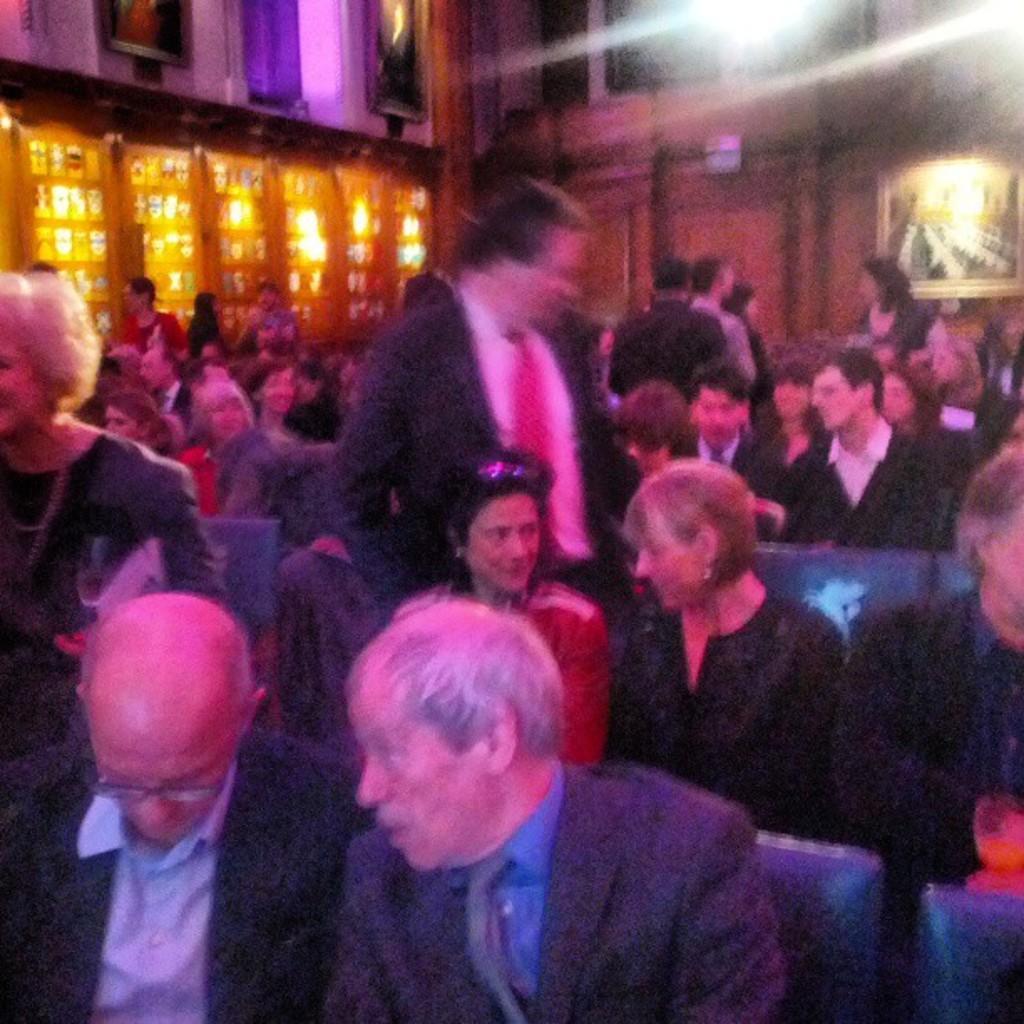In one or two sentences, can you explain what this image depicts? In the picture there are many people present sitting on the chair, there is a wall, on the wall there are lights present, there are frames present. 